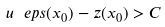Convert formula to latex. <formula><loc_0><loc_0><loc_500><loc_500>u _ { \ } e p s ( x _ { 0 } ) - z ( x _ { 0 } ) > C</formula> 